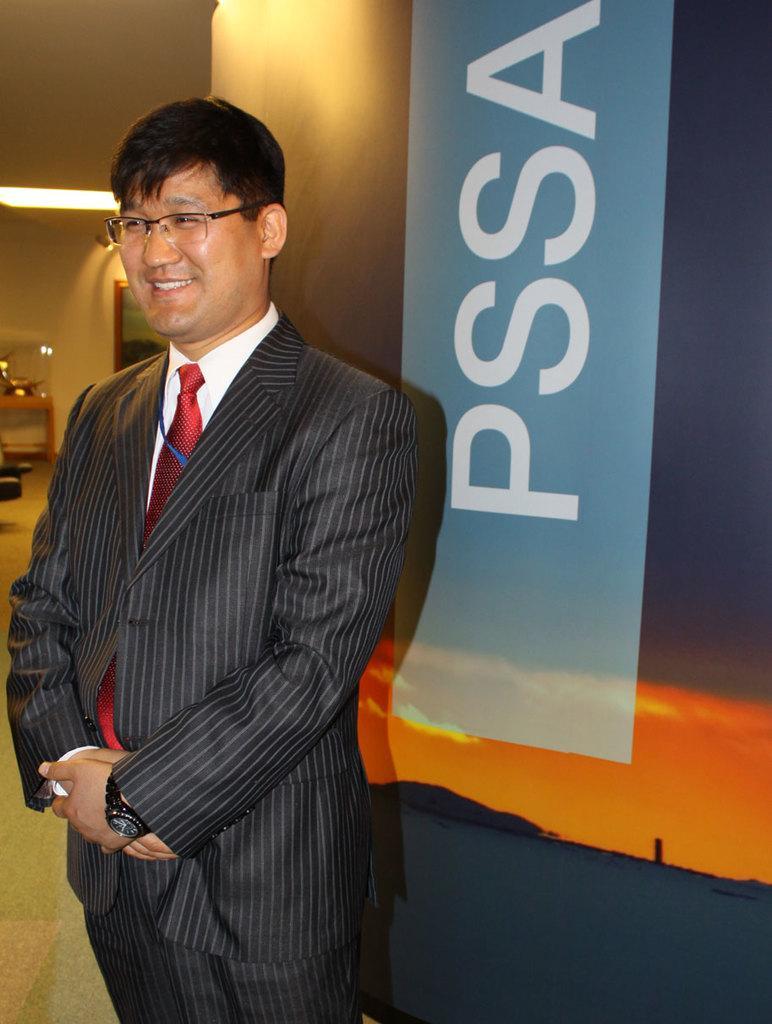Describe this image in one or two sentences. This image is taken indoors. In the background there is a wall with a picture frame on it. There are a few objects and there is a light. There is a banner with a text on it. In the middle of the image a man is standing and he is with a smiling face. 